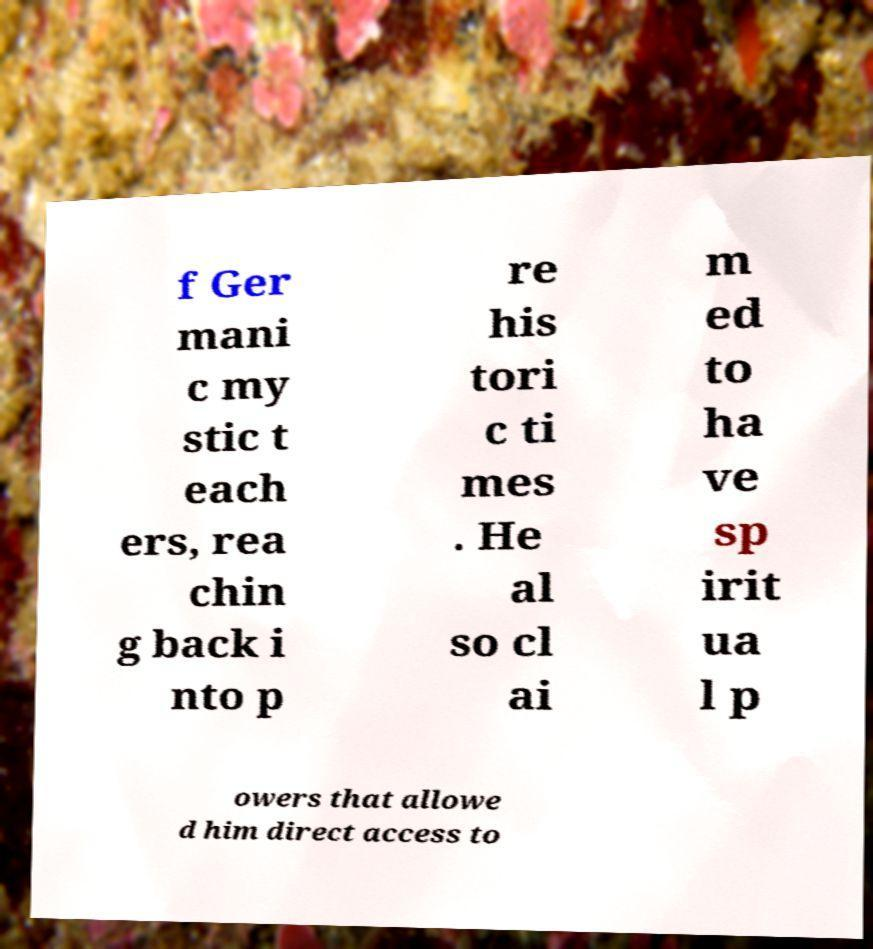Could you assist in decoding the text presented in this image and type it out clearly? f Ger mani c my stic t each ers, rea chin g back i nto p re his tori c ti mes . He al so cl ai m ed to ha ve sp irit ua l p owers that allowe d him direct access to 